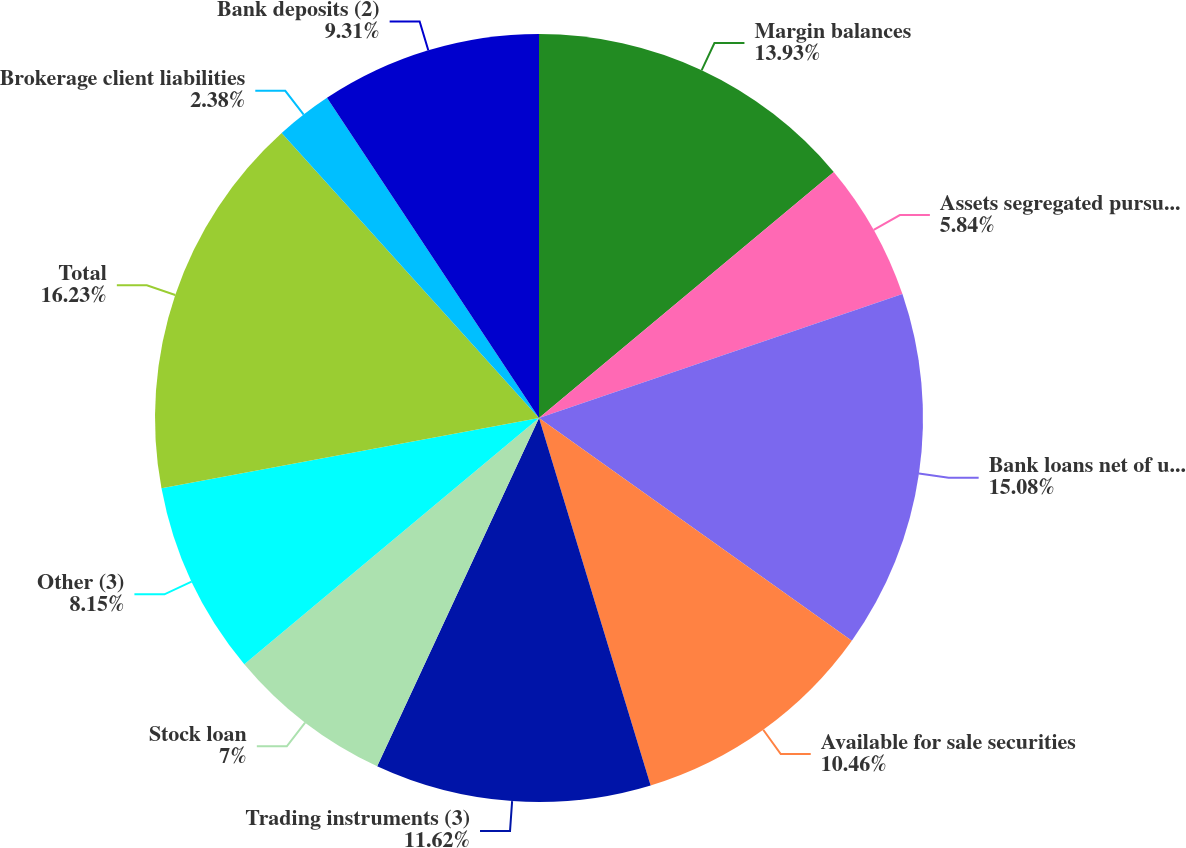<chart> <loc_0><loc_0><loc_500><loc_500><pie_chart><fcel>Margin balances<fcel>Assets segregated pursuant to<fcel>Bank loans net of unearned<fcel>Available for sale securities<fcel>Trading instruments (3)<fcel>Stock loan<fcel>Other (3)<fcel>Total<fcel>Brokerage client liabilities<fcel>Bank deposits (2)<nl><fcel>13.93%<fcel>5.84%<fcel>15.08%<fcel>10.46%<fcel>11.62%<fcel>7.0%<fcel>8.15%<fcel>16.24%<fcel>2.38%<fcel>9.31%<nl></chart> 